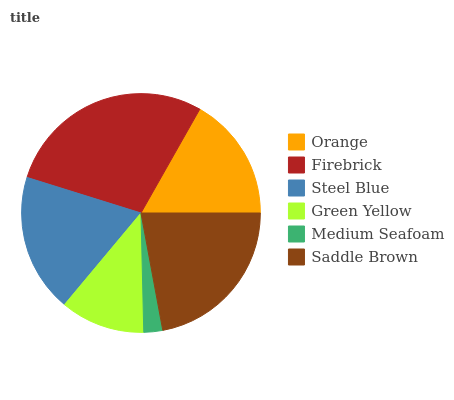Is Medium Seafoam the minimum?
Answer yes or no. Yes. Is Firebrick the maximum?
Answer yes or no. Yes. Is Steel Blue the minimum?
Answer yes or no. No. Is Steel Blue the maximum?
Answer yes or no. No. Is Firebrick greater than Steel Blue?
Answer yes or no. Yes. Is Steel Blue less than Firebrick?
Answer yes or no. Yes. Is Steel Blue greater than Firebrick?
Answer yes or no. No. Is Firebrick less than Steel Blue?
Answer yes or no. No. Is Steel Blue the high median?
Answer yes or no. Yes. Is Orange the low median?
Answer yes or no. Yes. Is Medium Seafoam the high median?
Answer yes or no. No. Is Firebrick the low median?
Answer yes or no. No. 